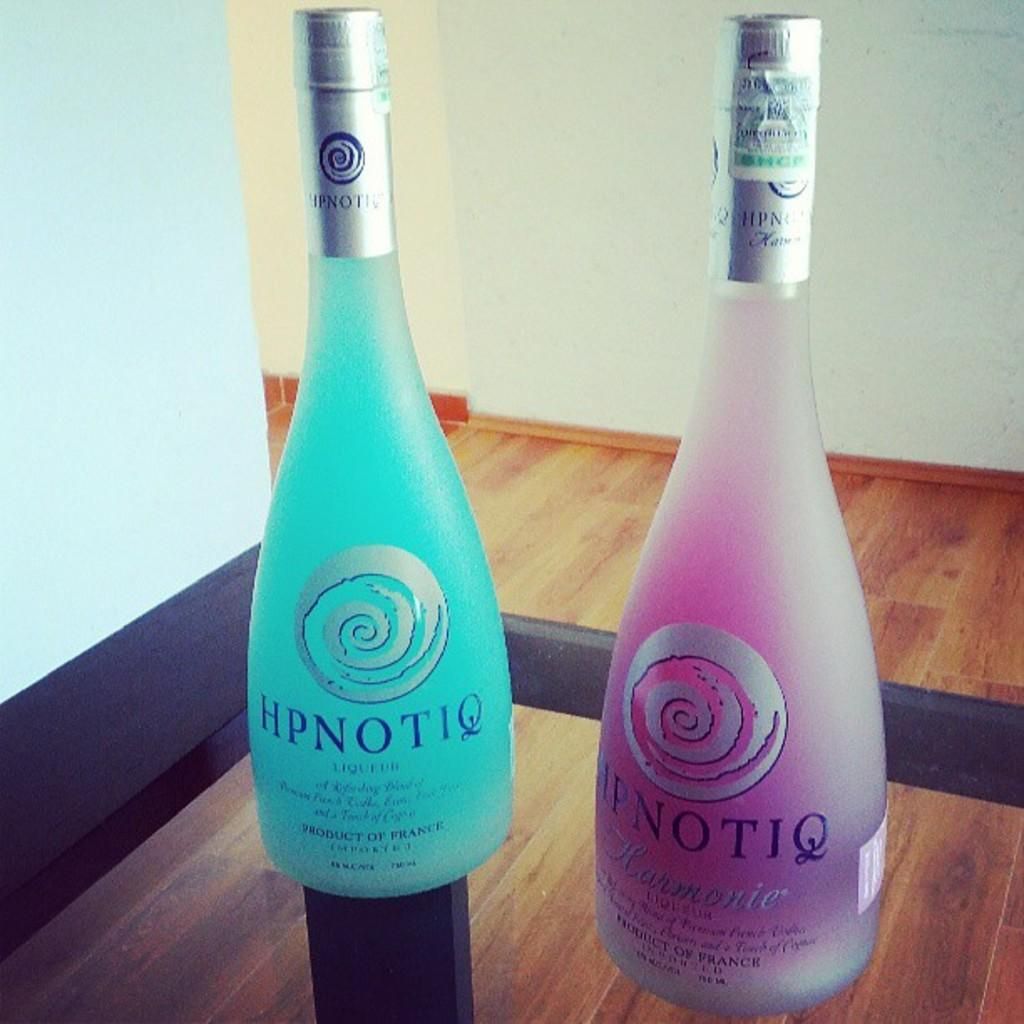Provide a one-sentence caption for the provided image. Two bottles of HPNOTIQ sit next to each other in a display. 